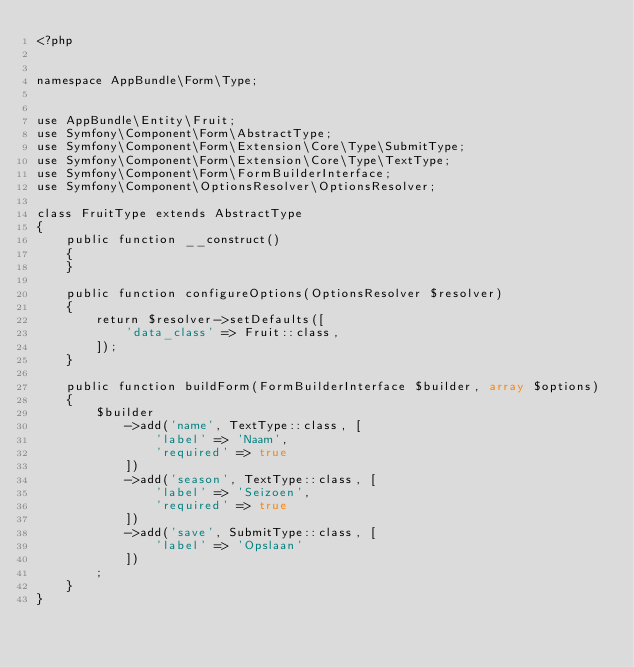<code> <loc_0><loc_0><loc_500><loc_500><_PHP_><?php


namespace AppBundle\Form\Type;


use AppBundle\Entity\Fruit;
use Symfony\Component\Form\AbstractType;
use Symfony\Component\Form\Extension\Core\Type\SubmitType;
use Symfony\Component\Form\Extension\Core\Type\TextType;
use Symfony\Component\Form\FormBuilderInterface;
use Symfony\Component\OptionsResolver\OptionsResolver;

class FruitType extends AbstractType
{
    public function __construct()
    {
    }

    public function configureOptions(OptionsResolver $resolver)
    {
        return $resolver->setDefaults([
            'data_class' => Fruit::class,
        ]);
    }

    public function buildForm(FormBuilderInterface $builder, array $options)
    {
        $builder
            ->add('name', TextType::class, [
                'label' => 'Naam',
                'required' => true
            ])
            ->add('season', TextType::class, [
                'label' => 'Seizoen',
                'required' => true
            ])
            ->add('save', SubmitType::class, [
                'label' => 'Opslaan'
            ])
        ;
    }
}</code> 